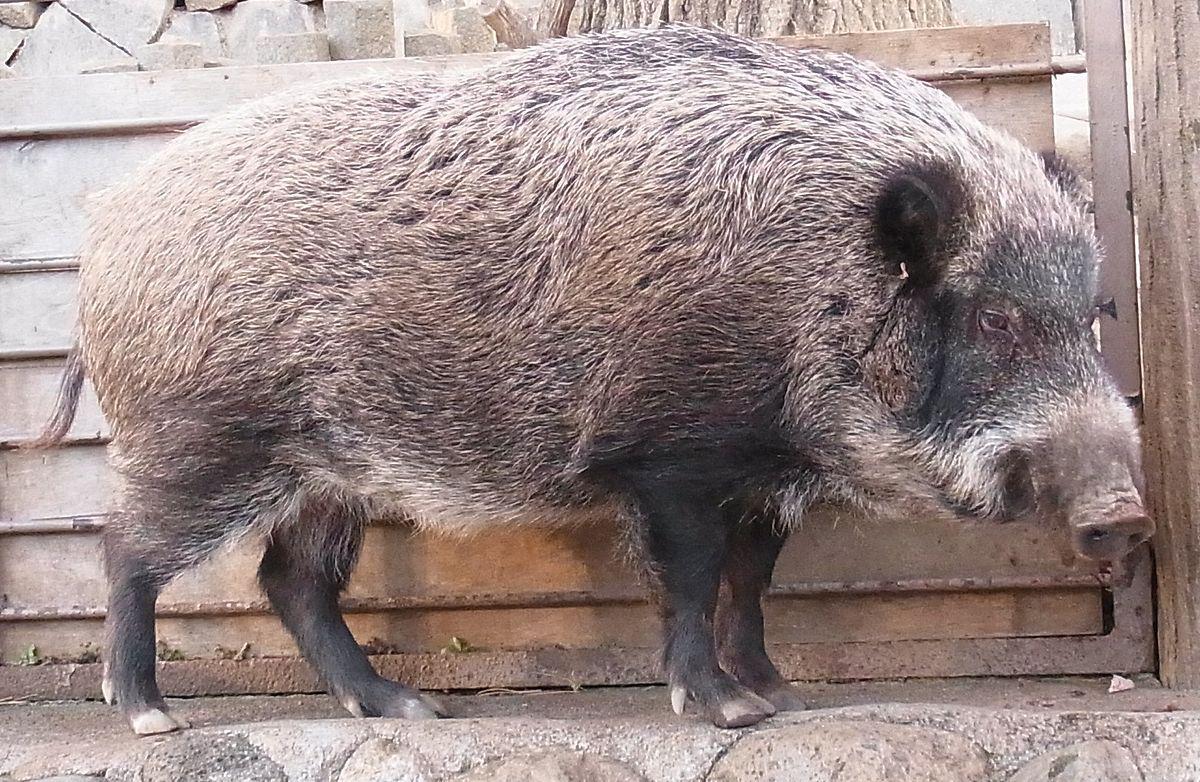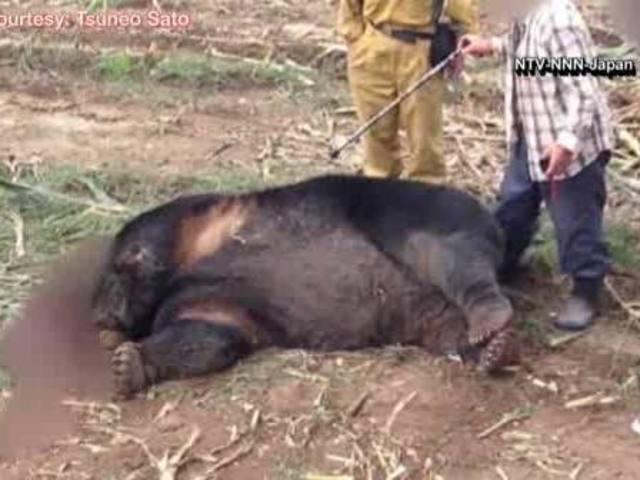The first image is the image on the left, the second image is the image on the right. Assess this claim about the two images: "A single animal is standing on the ground in the image on the right.". Correct or not? Answer yes or no. No. 